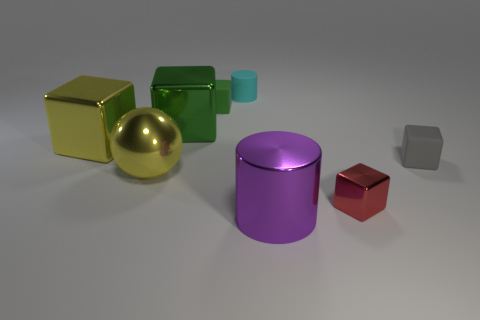Subtract all big metal cubes. How many cubes are left? 3 Subtract all purple spheres. How many green cubes are left? 2 Add 2 tiny brown things. How many objects exist? 10 Subtract all gray blocks. How many blocks are left? 4 Subtract all spheres. How many objects are left? 7 Subtract 2 cubes. How many cubes are left? 3 Subtract all brown blocks. Subtract all cyan cylinders. How many blocks are left? 5 Add 1 small green blocks. How many small green blocks exist? 2 Subtract 0 blue balls. How many objects are left? 8 Subtract all metallic cylinders. Subtract all green things. How many objects are left? 5 